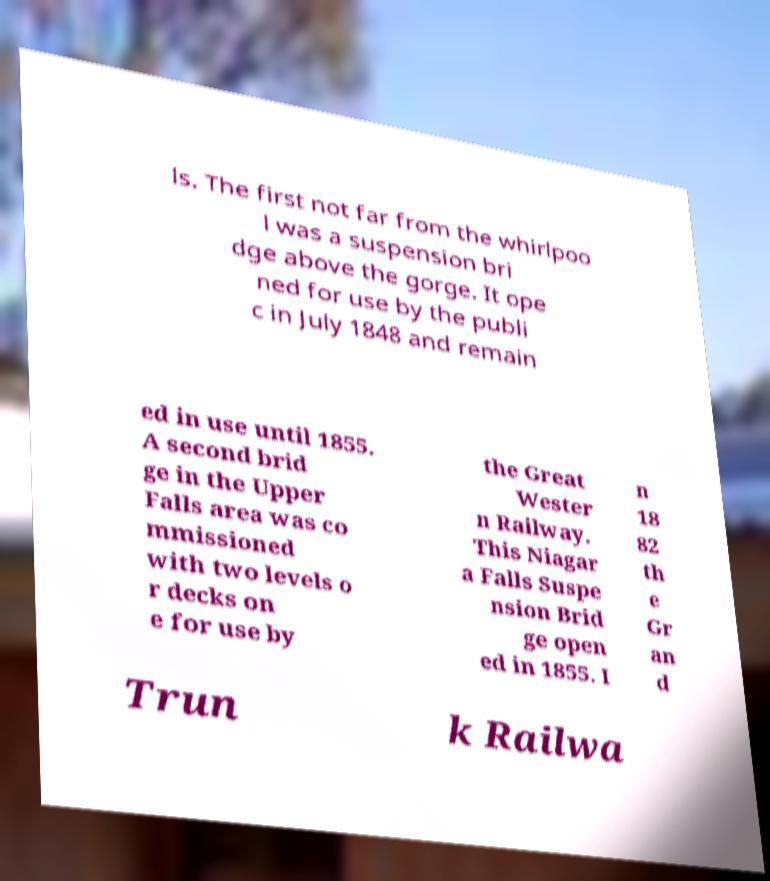There's text embedded in this image that I need extracted. Can you transcribe it verbatim? ls. The first not far from the whirlpoo l was a suspension bri dge above the gorge. It ope ned for use by the publi c in July 1848 and remain ed in use until 1855. A second brid ge in the Upper Falls area was co mmissioned with two levels o r decks on e for use by the Great Wester n Railway. This Niagar a Falls Suspe nsion Brid ge open ed in 1855. I n 18 82 th e Gr an d Trun k Railwa 